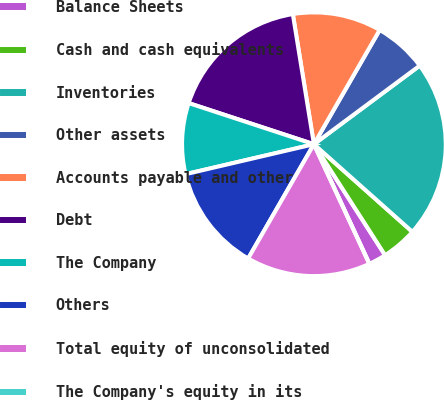Convert chart. <chart><loc_0><loc_0><loc_500><loc_500><pie_chart><fcel>Balance Sheets<fcel>Cash and cash equivalents<fcel>Inventories<fcel>Other assets<fcel>Accounts payable and other<fcel>Debt<fcel>The Company<fcel>Others<fcel>Total equity of unconsolidated<fcel>The Company's equity in its<nl><fcel>2.17%<fcel>4.35%<fcel>21.74%<fcel>6.52%<fcel>10.87%<fcel>17.39%<fcel>8.7%<fcel>13.04%<fcel>15.22%<fcel>0.0%<nl></chart> 